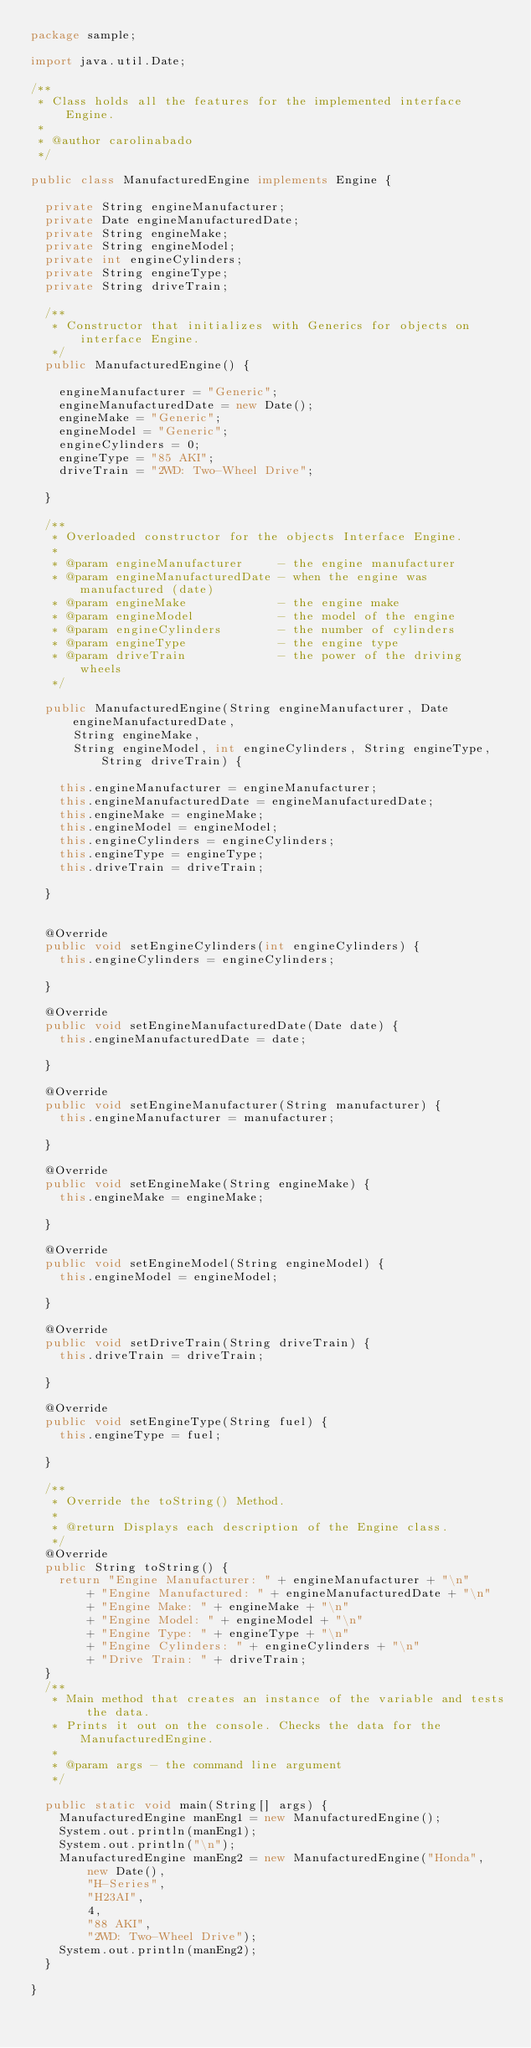Convert code to text. <code><loc_0><loc_0><loc_500><loc_500><_Java_>package sample;

import java.util.Date;

/**
 * Class holds all the features for the implemented interface Engine.
 *
 * @author carolinabado
 */

public class ManufacturedEngine implements Engine {

  private String engineManufacturer;
  private Date engineManufacturedDate;
  private String engineMake;
  private String engineModel;
  private int engineCylinders;
  private String engineType;
  private String driveTrain;

  /**
   * Constructor that initializes with Generics for objects on interface Engine.
   */
  public ManufacturedEngine() {

    engineManufacturer = "Generic";
    engineManufacturedDate = new Date();
    engineMake = "Generic";
    engineModel = "Generic";
    engineCylinders = 0;
    engineType = "85 AKI";
    driveTrain = "2WD: Two-Wheel Drive";

  }

  /**
   * Overloaded constructor for the objects Interface Engine.
   *
   * @param engineManufacturer     - the engine manufacturer
   * @param engineManufacturedDate - when the engine was manufactured (date)
   * @param engineMake             - the engine make
   * @param engineModel            - the model of the engine
   * @param engineCylinders        - the number of cylinders
   * @param engineType             - the engine type
   * @param driveTrain             - the power of the driving wheels
   */

  public ManufacturedEngine(String engineManufacturer, Date engineManufacturedDate,
      String engineMake,
      String engineModel, int engineCylinders, String engineType, String driveTrain) {

    this.engineManufacturer = engineManufacturer;
    this.engineManufacturedDate = engineManufacturedDate;
    this.engineMake = engineMake;
    this.engineModel = engineModel;
    this.engineCylinders = engineCylinders;
    this.engineType = engineType;
    this.driveTrain = driveTrain;

  }


  @Override
  public void setEngineCylinders(int engineCylinders) {
    this.engineCylinders = engineCylinders;

  }

  @Override
  public void setEngineManufacturedDate(Date date) {
    this.engineManufacturedDate = date;

  }

  @Override
  public void setEngineManufacturer(String manufacturer) {
    this.engineManufacturer = manufacturer;

  }

  @Override
  public void setEngineMake(String engineMake) {
    this.engineMake = engineMake;

  }

  @Override
  public void setEngineModel(String engineModel) {
    this.engineModel = engineModel;

  }

  @Override
  public void setDriveTrain(String driveTrain) {
    this.driveTrain = driveTrain;

  }

  @Override
  public void setEngineType(String fuel) {
    this.engineType = fuel;

  }

  /**
   * Override the toString() Method.
   *
   * @return Displays each description of the Engine class.
   */
  @Override
  public String toString() {
    return "Engine Manufacturer: " + engineManufacturer + "\n"
        + "Engine Manufactured: " + engineManufacturedDate + "\n"
        + "Engine Make: " + engineMake + "\n"
        + "Engine Model: " + engineModel + "\n"
        + "Engine Type: " + engineType + "\n"
        + "Engine Cylinders: " + engineCylinders + "\n"
        + "Drive Train: " + driveTrain;
  }
  /**
   * Main method that creates an instance of the variable and tests the data.
   * Prints it out on the console. Checks the data for the ManufacturedEngine.
   *
   * @param args - the command line argument
   */

  public static void main(String[] args) {
    ManufacturedEngine manEng1 = new ManufacturedEngine();
    System.out.println(manEng1);
    System.out.println("\n");
    ManufacturedEngine manEng2 = new ManufacturedEngine("Honda",
        new Date(),
        "H-Series",
        "H23AI",
        4,
        "88 AKI",
        "2WD: Two-Wheel Drive");
    System.out.println(manEng2);
  }

}
</code> 